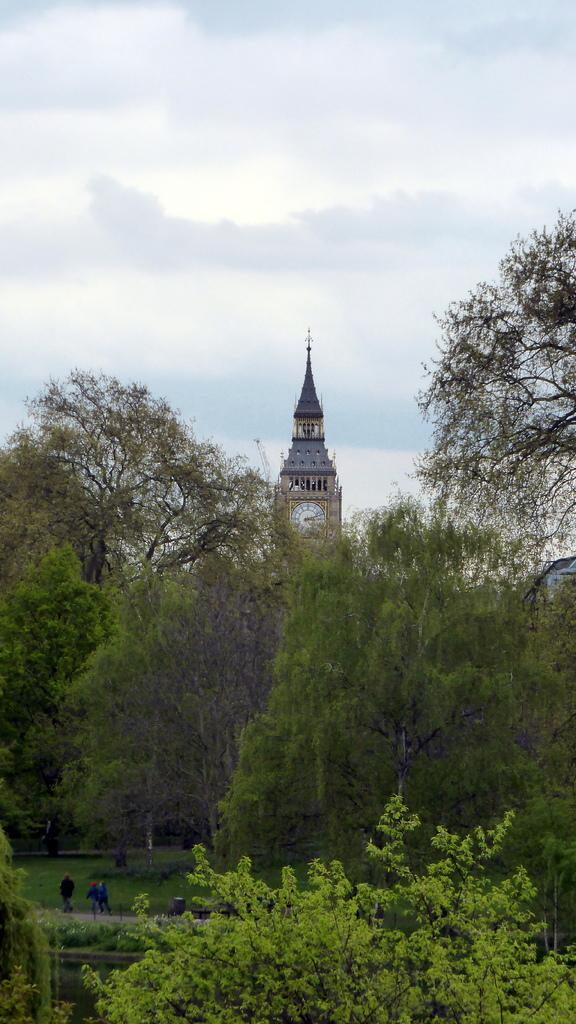What is the main structure in the center of the image? There is a tower in the center of the image. What type of vegetation can be seen in the image? There are trees in the image. What is visible at the top of the image? The sky is visible at the top of the image. What color is the paint on the thought in the image? There is no paint or thought present in the image; it features a tower and trees. 